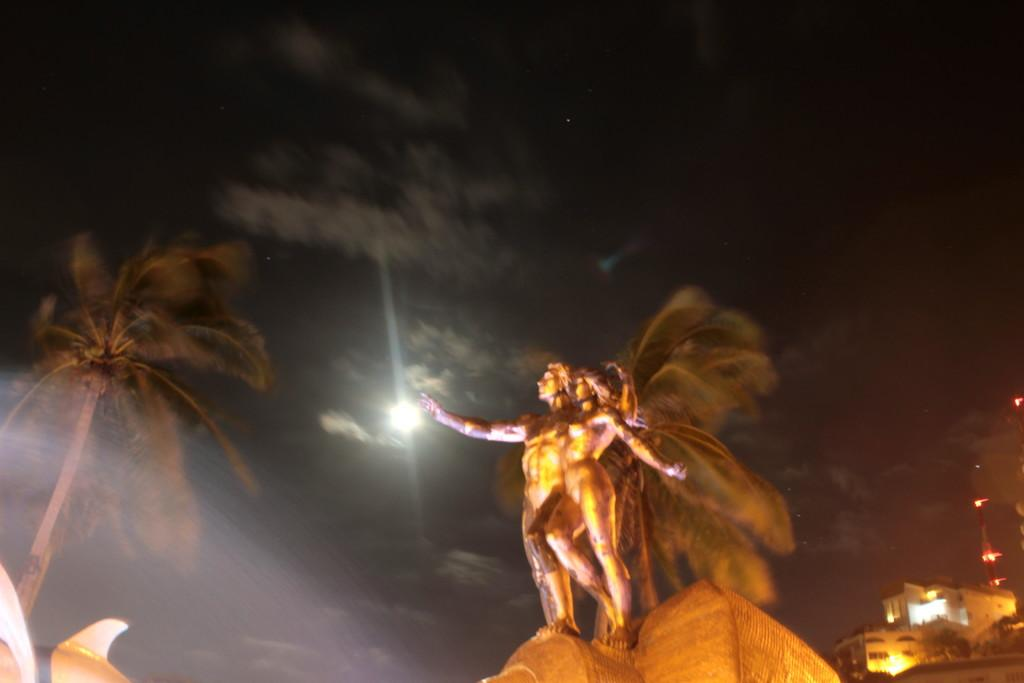What can be seen on the platform in the image? There are sculptures of two people on a platform in the image. What type of natural elements are present in the image? There are trees in the image. What can be seen in the distance in the image? There are buildings in the background of the image. Are there any additional trees visible in the background? Yes, there are more trees in the background of the image. What else can be seen in the background of the image? There are lights and the sky with clouds visible in the background of the image. What type of system is being used by the son in the image? There is no son or system present in the image; it features sculptures of two people on a platform with trees, buildings, lights, and the sky visible in the background. 